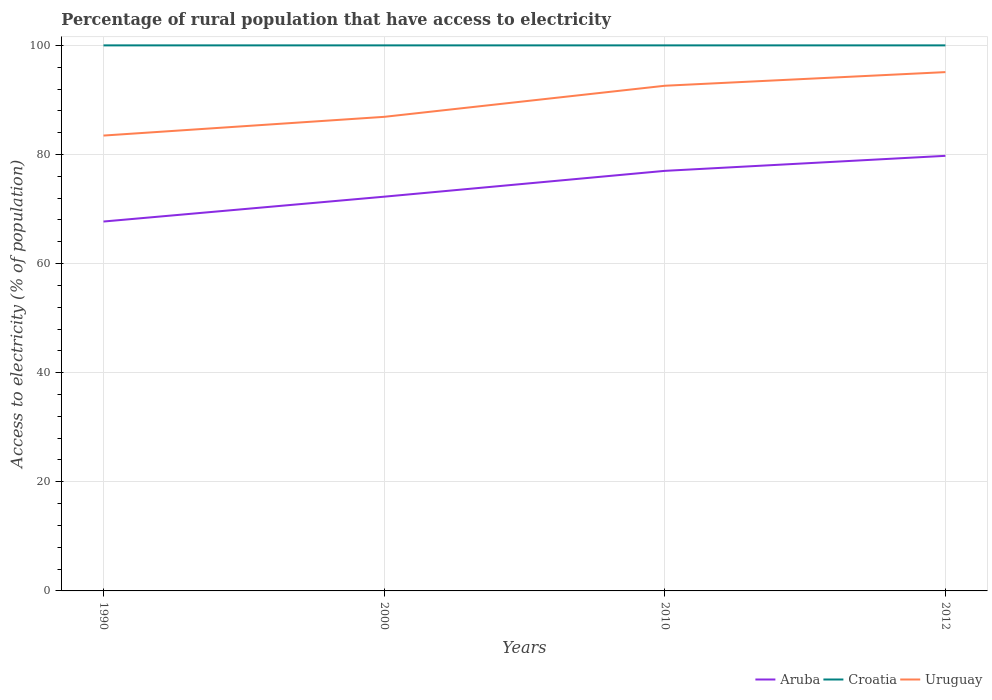How many different coloured lines are there?
Your answer should be compact. 3. Does the line corresponding to Croatia intersect with the line corresponding to Aruba?
Give a very brief answer. No. Across all years, what is the maximum percentage of rural population that have access to electricity in Aruba?
Make the answer very short. 67.71. In which year was the percentage of rural population that have access to electricity in Uruguay maximum?
Offer a terse response. 1990. What is the total percentage of rural population that have access to electricity in Uruguay in the graph?
Ensure brevity in your answer.  -11.63. What is the difference between the highest and the second highest percentage of rural population that have access to electricity in Uruguay?
Keep it short and to the point. 11.63. What is the difference between the highest and the lowest percentage of rural population that have access to electricity in Croatia?
Provide a succinct answer. 0. What is the difference between two consecutive major ticks on the Y-axis?
Keep it short and to the point. 20. Are the values on the major ticks of Y-axis written in scientific E-notation?
Your answer should be very brief. No. Does the graph contain any zero values?
Ensure brevity in your answer.  No. Does the graph contain grids?
Provide a short and direct response. Yes. Where does the legend appear in the graph?
Your answer should be very brief. Bottom right. How many legend labels are there?
Offer a very short reply. 3. How are the legend labels stacked?
Provide a succinct answer. Horizontal. What is the title of the graph?
Offer a terse response. Percentage of rural population that have access to electricity. Does "Mozambique" appear as one of the legend labels in the graph?
Offer a very short reply. No. What is the label or title of the X-axis?
Offer a terse response. Years. What is the label or title of the Y-axis?
Offer a very short reply. Access to electricity (% of population). What is the Access to electricity (% of population) in Aruba in 1990?
Give a very brief answer. 67.71. What is the Access to electricity (% of population) of Croatia in 1990?
Your response must be concise. 100. What is the Access to electricity (% of population) in Uruguay in 1990?
Keep it short and to the point. 83.47. What is the Access to electricity (% of population) in Aruba in 2000?
Ensure brevity in your answer.  72.27. What is the Access to electricity (% of population) of Croatia in 2000?
Offer a terse response. 100. What is the Access to electricity (% of population) of Uruguay in 2000?
Your answer should be compact. 86.9. What is the Access to electricity (% of population) of Croatia in 2010?
Your answer should be very brief. 100. What is the Access to electricity (% of population) in Uruguay in 2010?
Keep it short and to the point. 92.6. What is the Access to electricity (% of population) of Aruba in 2012?
Offer a very short reply. 79.75. What is the Access to electricity (% of population) of Uruguay in 2012?
Keep it short and to the point. 95.1. Across all years, what is the maximum Access to electricity (% of population) in Aruba?
Provide a short and direct response. 79.75. Across all years, what is the maximum Access to electricity (% of population) of Uruguay?
Offer a terse response. 95.1. Across all years, what is the minimum Access to electricity (% of population) in Aruba?
Keep it short and to the point. 67.71. Across all years, what is the minimum Access to electricity (% of population) of Uruguay?
Provide a short and direct response. 83.47. What is the total Access to electricity (% of population) in Aruba in the graph?
Your response must be concise. 296.73. What is the total Access to electricity (% of population) in Uruguay in the graph?
Provide a succinct answer. 358.07. What is the difference between the Access to electricity (% of population) of Aruba in 1990 and that in 2000?
Make the answer very short. -4.55. What is the difference between the Access to electricity (% of population) of Uruguay in 1990 and that in 2000?
Offer a very short reply. -3.43. What is the difference between the Access to electricity (% of population) in Aruba in 1990 and that in 2010?
Provide a short and direct response. -9.29. What is the difference between the Access to electricity (% of population) of Croatia in 1990 and that in 2010?
Provide a succinct answer. 0. What is the difference between the Access to electricity (% of population) in Uruguay in 1990 and that in 2010?
Ensure brevity in your answer.  -9.13. What is the difference between the Access to electricity (% of population) in Aruba in 1990 and that in 2012?
Ensure brevity in your answer.  -12.04. What is the difference between the Access to electricity (% of population) in Croatia in 1990 and that in 2012?
Keep it short and to the point. 0. What is the difference between the Access to electricity (% of population) of Uruguay in 1990 and that in 2012?
Offer a very short reply. -11.63. What is the difference between the Access to electricity (% of population) of Aruba in 2000 and that in 2010?
Your answer should be compact. -4.74. What is the difference between the Access to electricity (% of population) in Croatia in 2000 and that in 2010?
Make the answer very short. 0. What is the difference between the Access to electricity (% of population) in Aruba in 2000 and that in 2012?
Ensure brevity in your answer.  -7.49. What is the difference between the Access to electricity (% of population) of Croatia in 2000 and that in 2012?
Make the answer very short. 0. What is the difference between the Access to electricity (% of population) in Uruguay in 2000 and that in 2012?
Provide a short and direct response. -8.2. What is the difference between the Access to electricity (% of population) in Aruba in 2010 and that in 2012?
Ensure brevity in your answer.  -2.75. What is the difference between the Access to electricity (% of population) in Aruba in 1990 and the Access to electricity (% of population) in Croatia in 2000?
Your answer should be compact. -32.29. What is the difference between the Access to electricity (% of population) in Aruba in 1990 and the Access to electricity (% of population) in Uruguay in 2000?
Give a very brief answer. -19.19. What is the difference between the Access to electricity (% of population) of Aruba in 1990 and the Access to electricity (% of population) of Croatia in 2010?
Offer a terse response. -32.29. What is the difference between the Access to electricity (% of population) in Aruba in 1990 and the Access to electricity (% of population) in Uruguay in 2010?
Offer a very short reply. -24.89. What is the difference between the Access to electricity (% of population) in Croatia in 1990 and the Access to electricity (% of population) in Uruguay in 2010?
Make the answer very short. 7.4. What is the difference between the Access to electricity (% of population) of Aruba in 1990 and the Access to electricity (% of population) of Croatia in 2012?
Your response must be concise. -32.29. What is the difference between the Access to electricity (% of population) of Aruba in 1990 and the Access to electricity (% of population) of Uruguay in 2012?
Your response must be concise. -27.39. What is the difference between the Access to electricity (% of population) in Aruba in 2000 and the Access to electricity (% of population) in Croatia in 2010?
Give a very brief answer. -27.73. What is the difference between the Access to electricity (% of population) in Aruba in 2000 and the Access to electricity (% of population) in Uruguay in 2010?
Keep it short and to the point. -20.34. What is the difference between the Access to electricity (% of population) in Croatia in 2000 and the Access to electricity (% of population) in Uruguay in 2010?
Give a very brief answer. 7.4. What is the difference between the Access to electricity (% of population) in Aruba in 2000 and the Access to electricity (% of population) in Croatia in 2012?
Offer a terse response. -27.73. What is the difference between the Access to electricity (% of population) of Aruba in 2000 and the Access to electricity (% of population) of Uruguay in 2012?
Offer a terse response. -22.84. What is the difference between the Access to electricity (% of population) in Aruba in 2010 and the Access to electricity (% of population) in Croatia in 2012?
Make the answer very short. -23. What is the difference between the Access to electricity (% of population) of Aruba in 2010 and the Access to electricity (% of population) of Uruguay in 2012?
Offer a very short reply. -18.1. What is the difference between the Access to electricity (% of population) in Croatia in 2010 and the Access to electricity (% of population) in Uruguay in 2012?
Provide a short and direct response. 4.9. What is the average Access to electricity (% of population) in Aruba per year?
Provide a short and direct response. 74.18. What is the average Access to electricity (% of population) of Croatia per year?
Offer a terse response. 100. What is the average Access to electricity (% of population) in Uruguay per year?
Your answer should be compact. 89.52. In the year 1990, what is the difference between the Access to electricity (% of population) of Aruba and Access to electricity (% of population) of Croatia?
Ensure brevity in your answer.  -32.29. In the year 1990, what is the difference between the Access to electricity (% of population) of Aruba and Access to electricity (% of population) of Uruguay?
Provide a short and direct response. -15.76. In the year 1990, what is the difference between the Access to electricity (% of population) in Croatia and Access to electricity (% of population) in Uruguay?
Make the answer very short. 16.53. In the year 2000, what is the difference between the Access to electricity (% of population) of Aruba and Access to electricity (% of population) of Croatia?
Make the answer very short. -27.73. In the year 2000, what is the difference between the Access to electricity (% of population) in Aruba and Access to electricity (% of population) in Uruguay?
Give a very brief answer. -14.63. In the year 2000, what is the difference between the Access to electricity (% of population) of Croatia and Access to electricity (% of population) of Uruguay?
Offer a very short reply. 13.1. In the year 2010, what is the difference between the Access to electricity (% of population) of Aruba and Access to electricity (% of population) of Croatia?
Provide a succinct answer. -23. In the year 2010, what is the difference between the Access to electricity (% of population) of Aruba and Access to electricity (% of population) of Uruguay?
Ensure brevity in your answer.  -15.6. In the year 2010, what is the difference between the Access to electricity (% of population) in Croatia and Access to electricity (% of population) in Uruguay?
Provide a succinct answer. 7.4. In the year 2012, what is the difference between the Access to electricity (% of population) in Aruba and Access to electricity (% of population) in Croatia?
Offer a terse response. -20.25. In the year 2012, what is the difference between the Access to electricity (% of population) in Aruba and Access to electricity (% of population) in Uruguay?
Your response must be concise. -15.35. In the year 2012, what is the difference between the Access to electricity (% of population) in Croatia and Access to electricity (% of population) in Uruguay?
Make the answer very short. 4.9. What is the ratio of the Access to electricity (% of population) in Aruba in 1990 to that in 2000?
Offer a terse response. 0.94. What is the ratio of the Access to electricity (% of population) of Croatia in 1990 to that in 2000?
Your answer should be very brief. 1. What is the ratio of the Access to electricity (% of population) in Uruguay in 1990 to that in 2000?
Provide a succinct answer. 0.96. What is the ratio of the Access to electricity (% of population) in Aruba in 1990 to that in 2010?
Your answer should be very brief. 0.88. What is the ratio of the Access to electricity (% of population) of Croatia in 1990 to that in 2010?
Provide a short and direct response. 1. What is the ratio of the Access to electricity (% of population) in Uruguay in 1990 to that in 2010?
Your answer should be very brief. 0.9. What is the ratio of the Access to electricity (% of population) of Aruba in 1990 to that in 2012?
Your answer should be very brief. 0.85. What is the ratio of the Access to electricity (% of population) of Croatia in 1990 to that in 2012?
Your answer should be compact. 1. What is the ratio of the Access to electricity (% of population) in Uruguay in 1990 to that in 2012?
Provide a succinct answer. 0.88. What is the ratio of the Access to electricity (% of population) of Aruba in 2000 to that in 2010?
Provide a short and direct response. 0.94. What is the ratio of the Access to electricity (% of population) in Croatia in 2000 to that in 2010?
Make the answer very short. 1. What is the ratio of the Access to electricity (% of population) of Uruguay in 2000 to that in 2010?
Your answer should be compact. 0.94. What is the ratio of the Access to electricity (% of population) of Aruba in 2000 to that in 2012?
Offer a very short reply. 0.91. What is the ratio of the Access to electricity (% of population) of Uruguay in 2000 to that in 2012?
Provide a succinct answer. 0.91. What is the ratio of the Access to electricity (% of population) of Aruba in 2010 to that in 2012?
Keep it short and to the point. 0.97. What is the ratio of the Access to electricity (% of population) in Uruguay in 2010 to that in 2012?
Your answer should be very brief. 0.97. What is the difference between the highest and the second highest Access to electricity (% of population) in Aruba?
Your answer should be very brief. 2.75. What is the difference between the highest and the second highest Access to electricity (% of population) of Uruguay?
Your answer should be compact. 2.5. What is the difference between the highest and the lowest Access to electricity (% of population) in Aruba?
Your answer should be very brief. 12.04. What is the difference between the highest and the lowest Access to electricity (% of population) of Uruguay?
Make the answer very short. 11.63. 